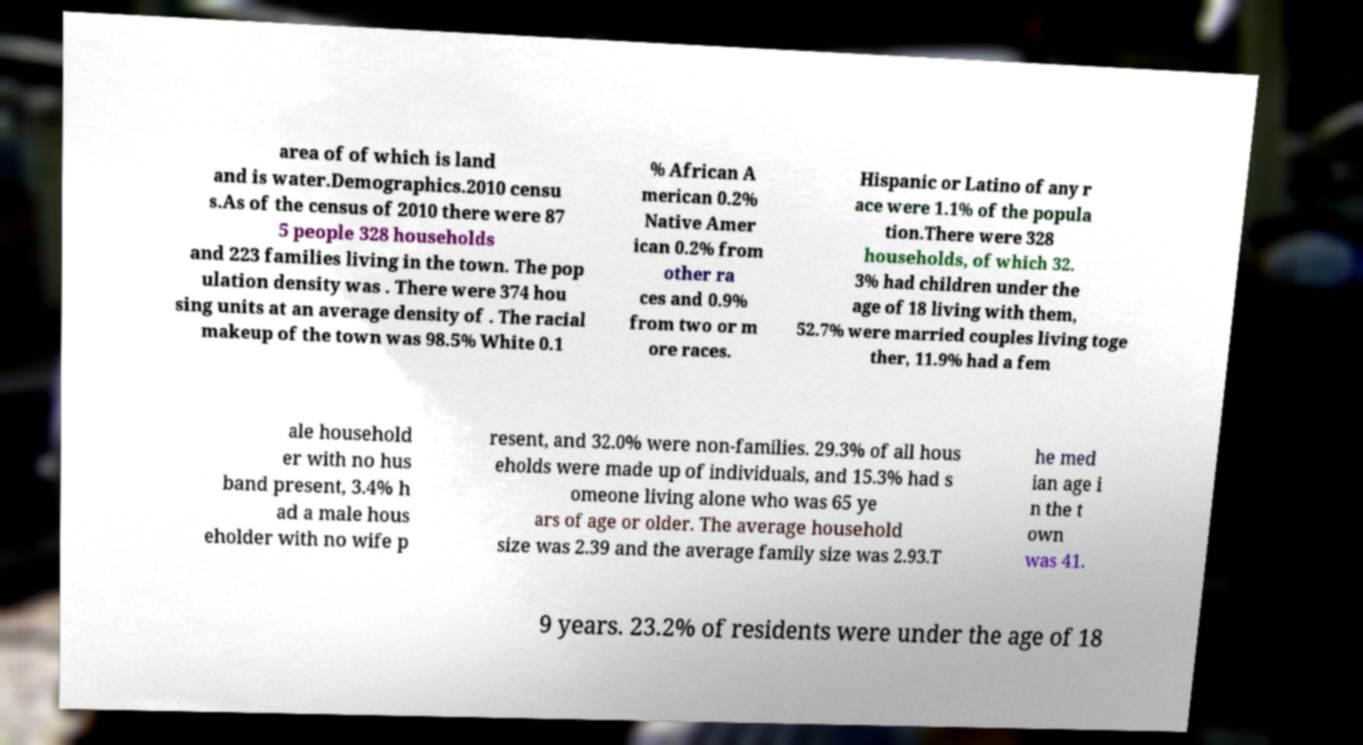Could you assist in decoding the text presented in this image and type it out clearly? area of of which is land and is water.Demographics.2010 censu s.As of the census of 2010 there were 87 5 people 328 households and 223 families living in the town. The pop ulation density was . There were 374 hou sing units at an average density of . The racial makeup of the town was 98.5% White 0.1 % African A merican 0.2% Native Amer ican 0.2% from other ra ces and 0.9% from two or m ore races. Hispanic or Latino of any r ace were 1.1% of the popula tion.There were 328 households, of which 32. 3% had children under the age of 18 living with them, 52.7% were married couples living toge ther, 11.9% had a fem ale household er with no hus band present, 3.4% h ad a male hous eholder with no wife p resent, and 32.0% were non-families. 29.3% of all hous eholds were made up of individuals, and 15.3% had s omeone living alone who was 65 ye ars of age or older. The average household size was 2.39 and the average family size was 2.93.T he med ian age i n the t own was 41. 9 years. 23.2% of residents were under the age of 18 